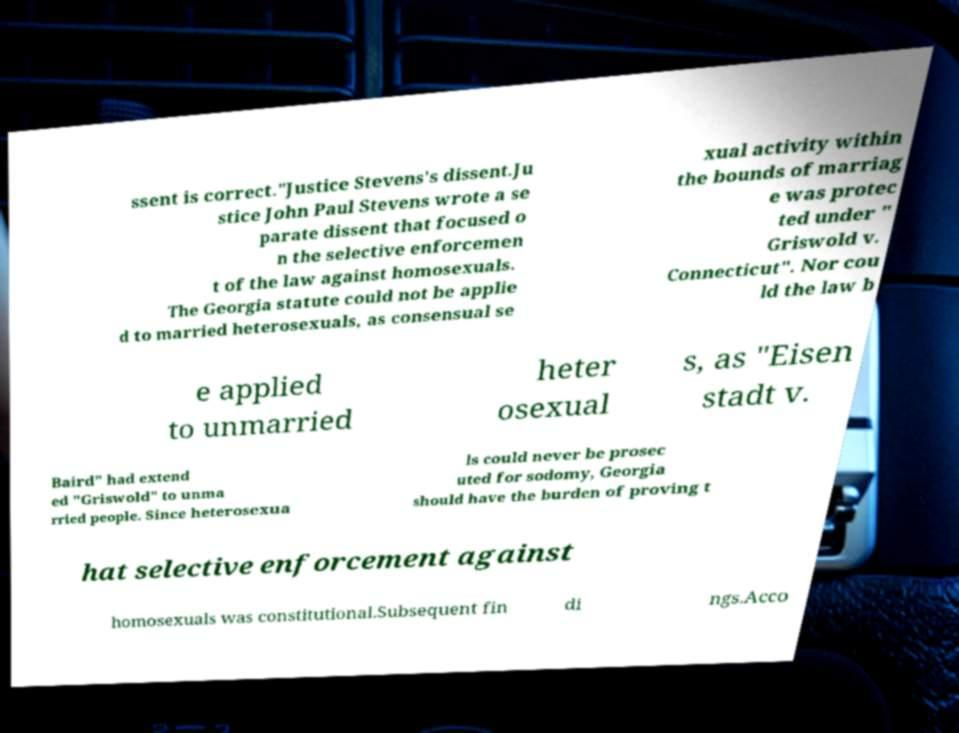Please identify and transcribe the text found in this image. ssent is correct."Justice Stevens's dissent.Ju stice John Paul Stevens wrote a se parate dissent that focused o n the selective enforcemen t of the law against homosexuals. The Georgia statute could not be applie d to married heterosexuals, as consensual se xual activity within the bounds of marriag e was protec ted under " Griswold v. Connecticut". Nor cou ld the law b e applied to unmarried heter osexual s, as "Eisen stadt v. Baird" had extend ed "Griswold" to unma rried people. Since heterosexua ls could never be prosec uted for sodomy, Georgia should have the burden of proving t hat selective enforcement against homosexuals was constitutional.Subsequent fin di ngs.Acco 